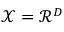<formula> <loc_0><loc_0><loc_500><loc_500>\mathcal { X } = \mathcal { R } ^ { D }</formula> 